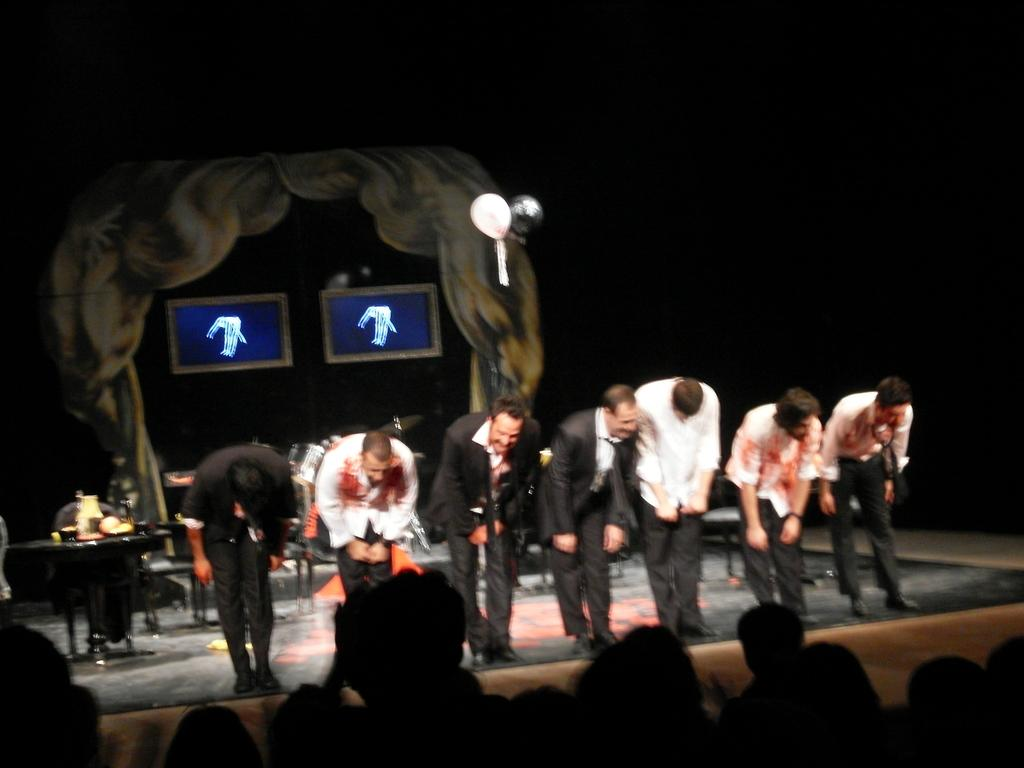How many people are in the image? There is a group of people in the image. Can you describe the attire of one person in the front? One person in front is wearing a black blazer, white shirt, and black pants. What can be seen in the background of the image? There are two screens and a curtain in white color in the background of the image. What type of cup is the father holding in the image? There is no father or cup present in the image. Can you tell me the story being told by the people in the image? The image does not depict a story being told; it is a group of people and their attire and surroundings. 